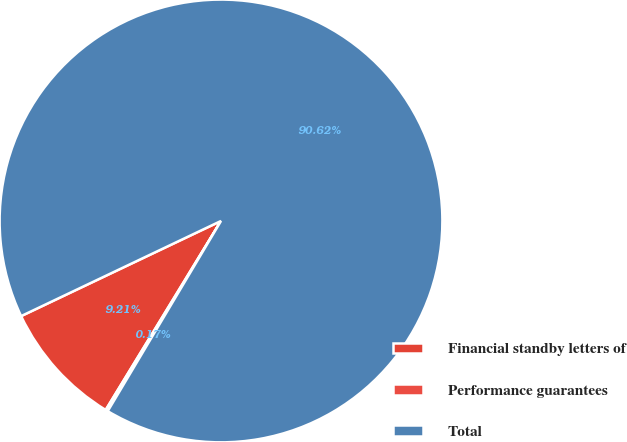Convert chart to OTSL. <chart><loc_0><loc_0><loc_500><loc_500><pie_chart><fcel>Financial standby letters of<fcel>Performance guarantees<fcel>Total<nl><fcel>9.21%<fcel>0.17%<fcel>90.62%<nl></chart> 